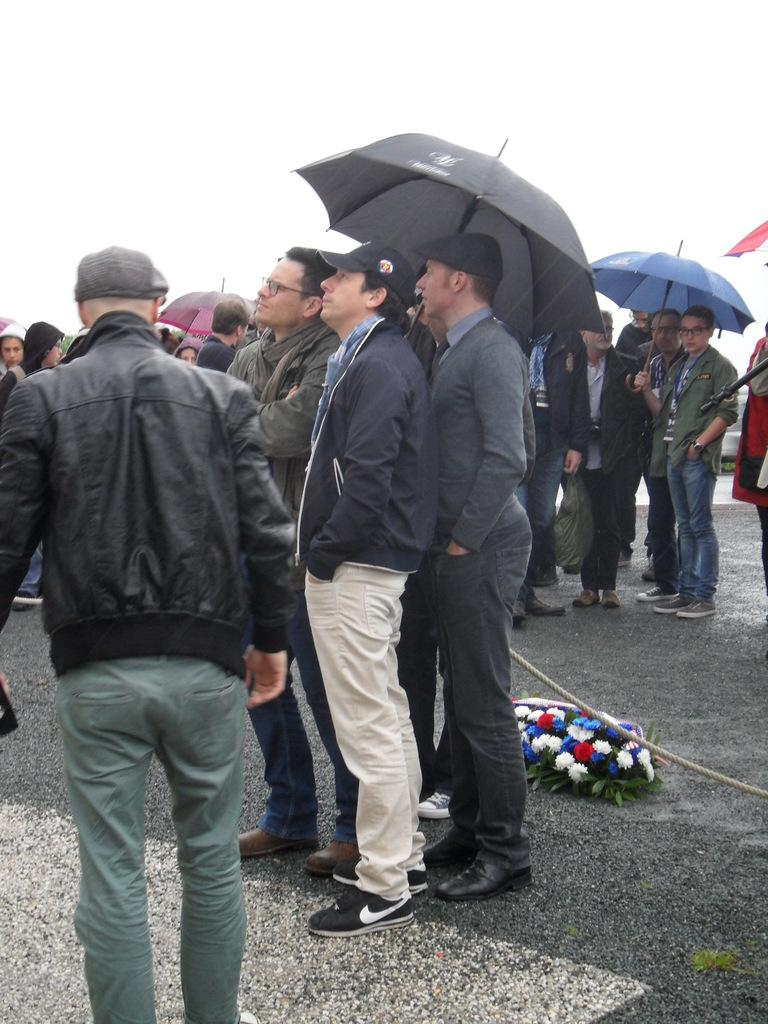How many people are in the image? There is a group of people in the image, but the exact number is not specified. Where are the people located in the image? The people are standing on the road in the image. What object can be seen in the image that is used for tying or securing? There is a rope in the image. What type of natural elements are present in the image? Flowers and leaves are visible in the image. What objects are in the image that can provide protection from the rain? Umbrellas are in the image. What can be seen in the background of the image? The sky is visible in the background of the image. What type of tax is being discussed by the people in the image? There is no indication in the image that the people are discussing any type of tax. 